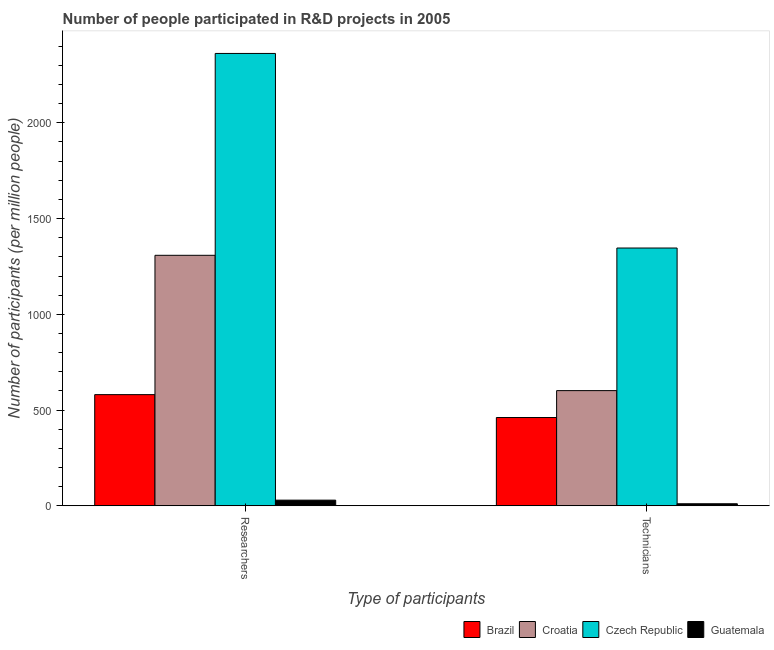How many groups of bars are there?
Provide a short and direct response. 2. Are the number of bars per tick equal to the number of legend labels?
Your response must be concise. Yes. Are the number of bars on each tick of the X-axis equal?
Provide a short and direct response. Yes. How many bars are there on the 2nd tick from the right?
Your response must be concise. 4. What is the label of the 2nd group of bars from the left?
Your response must be concise. Technicians. What is the number of researchers in Croatia?
Provide a short and direct response. 1308.11. Across all countries, what is the maximum number of technicians?
Give a very brief answer. 1346.19. Across all countries, what is the minimum number of researchers?
Your answer should be compact. 29.43. In which country was the number of researchers maximum?
Make the answer very short. Czech Republic. In which country was the number of technicians minimum?
Offer a very short reply. Guatemala. What is the total number of technicians in the graph?
Offer a terse response. 2419.05. What is the difference between the number of technicians in Brazil and that in Guatemala?
Keep it short and to the point. 450.37. What is the difference between the number of technicians in Guatemala and the number of researchers in Croatia?
Offer a very short reply. -1297.57. What is the average number of researchers per country?
Your response must be concise. 1070.1. What is the difference between the number of technicians and number of researchers in Brazil?
Your response must be concise. -119.57. What is the ratio of the number of researchers in Brazil to that in Guatemala?
Offer a very short reply. 19.72. Is the number of technicians in Czech Republic less than that in Guatemala?
Ensure brevity in your answer.  No. What does the 2nd bar from the left in Technicians represents?
Your answer should be very brief. Croatia. How many countries are there in the graph?
Make the answer very short. 4. What is the difference between two consecutive major ticks on the Y-axis?
Provide a succinct answer. 500. Are the values on the major ticks of Y-axis written in scientific E-notation?
Your answer should be very brief. No. Does the graph contain any zero values?
Offer a very short reply. No. Does the graph contain grids?
Offer a terse response. No. Where does the legend appear in the graph?
Provide a succinct answer. Bottom right. How many legend labels are there?
Your answer should be compact. 4. What is the title of the graph?
Your answer should be very brief. Number of people participated in R&D projects in 2005. Does "Bhutan" appear as one of the legend labels in the graph?
Your answer should be very brief. No. What is the label or title of the X-axis?
Offer a terse response. Type of participants. What is the label or title of the Y-axis?
Make the answer very short. Number of participants (per million people). What is the Number of participants (per million people) of Brazil in Researchers?
Your response must be concise. 580.49. What is the Number of participants (per million people) of Croatia in Researchers?
Ensure brevity in your answer.  1308.11. What is the Number of participants (per million people) of Czech Republic in Researchers?
Give a very brief answer. 2362.37. What is the Number of participants (per million people) in Guatemala in Researchers?
Ensure brevity in your answer.  29.43. What is the Number of participants (per million people) in Brazil in Technicians?
Offer a terse response. 460.92. What is the Number of participants (per million people) of Croatia in Technicians?
Provide a succinct answer. 601.41. What is the Number of participants (per million people) of Czech Republic in Technicians?
Offer a very short reply. 1346.19. What is the Number of participants (per million people) in Guatemala in Technicians?
Provide a succinct answer. 10.54. Across all Type of participants, what is the maximum Number of participants (per million people) in Brazil?
Offer a very short reply. 580.49. Across all Type of participants, what is the maximum Number of participants (per million people) of Croatia?
Give a very brief answer. 1308.11. Across all Type of participants, what is the maximum Number of participants (per million people) in Czech Republic?
Provide a short and direct response. 2362.37. Across all Type of participants, what is the maximum Number of participants (per million people) in Guatemala?
Give a very brief answer. 29.43. Across all Type of participants, what is the minimum Number of participants (per million people) of Brazil?
Provide a short and direct response. 460.92. Across all Type of participants, what is the minimum Number of participants (per million people) in Croatia?
Keep it short and to the point. 601.41. Across all Type of participants, what is the minimum Number of participants (per million people) of Czech Republic?
Your answer should be very brief. 1346.19. Across all Type of participants, what is the minimum Number of participants (per million people) in Guatemala?
Provide a succinct answer. 10.54. What is the total Number of participants (per million people) of Brazil in the graph?
Provide a short and direct response. 1041.4. What is the total Number of participants (per million people) of Croatia in the graph?
Offer a very short reply. 1909.52. What is the total Number of participants (per million people) of Czech Republic in the graph?
Provide a short and direct response. 3708.55. What is the total Number of participants (per million people) of Guatemala in the graph?
Make the answer very short. 39.97. What is the difference between the Number of participants (per million people) of Brazil in Researchers and that in Technicians?
Provide a succinct answer. 119.57. What is the difference between the Number of participants (per million people) of Croatia in Researchers and that in Technicians?
Keep it short and to the point. 706.71. What is the difference between the Number of participants (per million people) of Czech Republic in Researchers and that in Technicians?
Give a very brief answer. 1016.18. What is the difference between the Number of participants (per million people) in Guatemala in Researchers and that in Technicians?
Provide a succinct answer. 18.89. What is the difference between the Number of participants (per million people) in Brazil in Researchers and the Number of participants (per million people) in Croatia in Technicians?
Ensure brevity in your answer.  -20.92. What is the difference between the Number of participants (per million people) in Brazil in Researchers and the Number of participants (per million people) in Czech Republic in Technicians?
Make the answer very short. -765.7. What is the difference between the Number of participants (per million people) of Brazil in Researchers and the Number of participants (per million people) of Guatemala in Technicians?
Keep it short and to the point. 569.94. What is the difference between the Number of participants (per million people) in Croatia in Researchers and the Number of participants (per million people) in Czech Republic in Technicians?
Make the answer very short. -38.07. What is the difference between the Number of participants (per million people) of Croatia in Researchers and the Number of participants (per million people) of Guatemala in Technicians?
Your answer should be compact. 1297.57. What is the difference between the Number of participants (per million people) in Czech Republic in Researchers and the Number of participants (per million people) in Guatemala in Technicians?
Keep it short and to the point. 2351.82. What is the average Number of participants (per million people) in Brazil per Type of participants?
Give a very brief answer. 520.7. What is the average Number of participants (per million people) of Croatia per Type of participants?
Offer a very short reply. 954.76. What is the average Number of participants (per million people) in Czech Republic per Type of participants?
Provide a succinct answer. 1854.28. What is the average Number of participants (per million people) of Guatemala per Type of participants?
Your answer should be very brief. 19.99. What is the difference between the Number of participants (per million people) in Brazil and Number of participants (per million people) in Croatia in Researchers?
Offer a terse response. -727.63. What is the difference between the Number of participants (per million people) of Brazil and Number of participants (per million people) of Czech Republic in Researchers?
Offer a terse response. -1781.88. What is the difference between the Number of participants (per million people) of Brazil and Number of participants (per million people) of Guatemala in Researchers?
Provide a short and direct response. 551.06. What is the difference between the Number of participants (per million people) of Croatia and Number of participants (per million people) of Czech Republic in Researchers?
Provide a succinct answer. -1054.25. What is the difference between the Number of participants (per million people) of Croatia and Number of participants (per million people) of Guatemala in Researchers?
Your answer should be very brief. 1278.68. What is the difference between the Number of participants (per million people) in Czech Republic and Number of participants (per million people) in Guatemala in Researchers?
Offer a terse response. 2332.93. What is the difference between the Number of participants (per million people) of Brazil and Number of participants (per million people) of Croatia in Technicians?
Ensure brevity in your answer.  -140.49. What is the difference between the Number of participants (per million people) of Brazil and Number of participants (per million people) of Czech Republic in Technicians?
Provide a succinct answer. -885.27. What is the difference between the Number of participants (per million people) of Brazil and Number of participants (per million people) of Guatemala in Technicians?
Offer a terse response. 450.37. What is the difference between the Number of participants (per million people) in Croatia and Number of participants (per million people) in Czech Republic in Technicians?
Your answer should be very brief. -744.78. What is the difference between the Number of participants (per million people) of Croatia and Number of participants (per million people) of Guatemala in Technicians?
Your response must be concise. 590.87. What is the difference between the Number of participants (per million people) of Czech Republic and Number of participants (per million people) of Guatemala in Technicians?
Ensure brevity in your answer.  1335.64. What is the ratio of the Number of participants (per million people) of Brazil in Researchers to that in Technicians?
Ensure brevity in your answer.  1.26. What is the ratio of the Number of participants (per million people) in Croatia in Researchers to that in Technicians?
Offer a terse response. 2.18. What is the ratio of the Number of participants (per million people) in Czech Republic in Researchers to that in Technicians?
Make the answer very short. 1.75. What is the ratio of the Number of participants (per million people) in Guatemala in Researchers to that in Technicians?
Offer a very short reply. 2.79. What is the difference between the highest and the second highest Number of participants (per million people) of Brazil?
Make the answer very short. 119.57. What is the difference between the highest and the second highest Number of participants (per million people) of Croatia?
Make the answer very short. 706.71. What is the difference between the highest and the second highest Number of participants (per million people) of Czech Republic?
Your answer should be very brief. 1016.18. What is the difference between the highest and the second highest Number of participants (per million people) of Guatemala?
Keep it short and to the point. 18.89. What is the difference between the highest and the lowest Number of participants (per million people) in Brazil?
Make the answer very short. 119.57. What is the difference between the highest and the lowest Number of participants (per million people) of Croatia?
Provide a short and direct response. 706.71. What is the difference between the highest and the lowest Number of participants (per million people) of Czech Republic?
Make the answer very short. 1016.18. What is the difference between the highest and the lowest Number of participants (per million people) of Guatemala?
Provide a succinct answer. 18.89. 